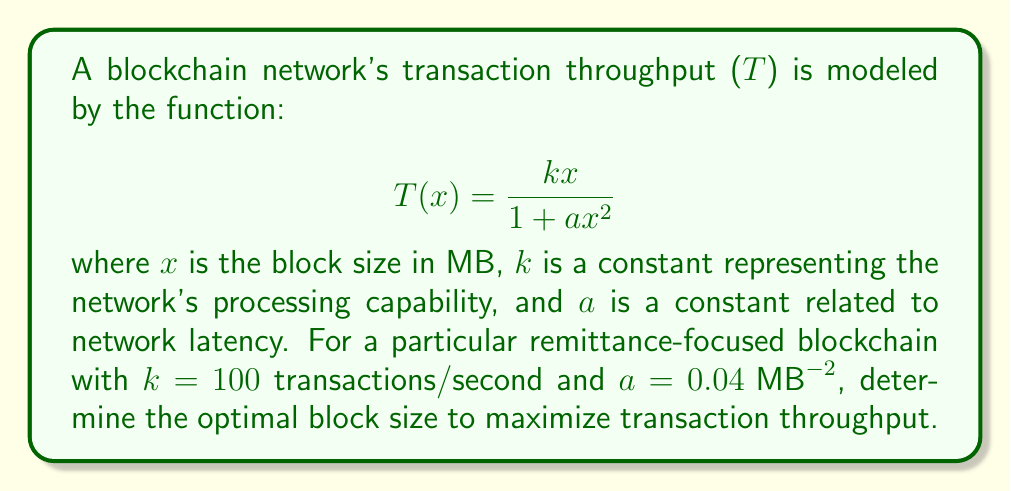Provide a solution to this math problem. To find the optimal block size that maximizes transaction throughput, we need to find the maximum of the function $T(x)$. This can be done by finding the critical point where the derivative of $T(x)$ equals zero.

1. Calculate the derivative of $T(x)$:
   $$T'(x) = \frac{k(1 + ax^2) - kx(2ax)}{(1 + ax^2)^2} = \frac{k - kax^2}{(1 + ax^2)^2}$$

2. Set $T'(x) = 0$ and solve for $x$:
   $$\frac{k - kax^2}{(1 + ax^2)^2} = 0$$
   $$k - kax^2 = 0$$
   $$1 - ax^2 = 0$$
   $$ax^2 = 1$$
   $$x^2 = \frac{1}{a}$$
   $$x = \sqrt{\frac{1}{a}}$$

3. Substitute the given values:
   $$x = \sqrt{\frac{1}{0.04}} = \sqrt{25} = 5\text{ MB}$$

4. Verify this is a maximum by checking the second derivative:
   $$T''(x) = \frac{-2kax(1 + ax^2)^2 - 2(1 + ax^2)(k - kax^2)(2ax)}{(1 + ax^2)^4}$$
   
   At $x = 5$, $T''(5) < 0$, confirming it's a maximum.

5. Calculate the maximum throughput:
   $$T(5) = \frac{100 \cdot 5}{1 + 0.04 \cdot 5^2} = \frac{500}{2} = 250\text{ transactions/second}$$

Therefore, the optimal block size is 5 MB, which results in a maximum throughput of 250 transactions per second for this remittance-focused blockchain network.
Answer: The optimal block size is 5 MB, resulting in a maximum throughput of 250 transactions per second. 